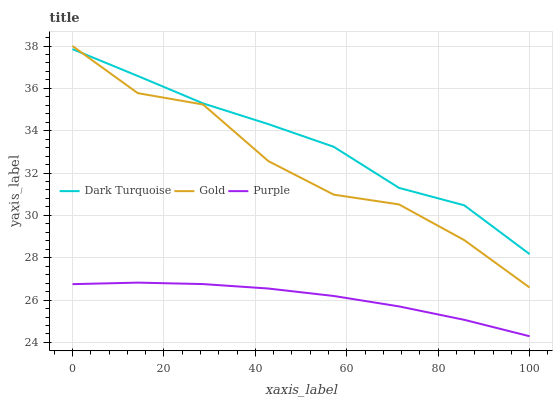Does Purple have the minimum area under the curve?
Answer yes or no. Yes. Does Dark Turquoise have the maximum area under the curve?
Answer yes or no. Yes. Does Gold have the minimum area under the curve?
Answer yes or no. No. Does Gold have the maximum area under the curve?
Answer yes or no. No. Is Purple the smoothest?
Answer yes or no. Yes. Is Gold the roughest?
Answer yes or no. Yes. Is Dark Turquoise the smoothest?
Answer yes or no. No. Is Dark Turquoise the roughest?
Answer yes or no. No. Does Purple have the lowest value?
Answer yes or no. Yes. Does Gold have the lowest value?
Answer yes or no. No. Does Gold have the highest value?
Answer yes or no. Yes. Does Dark Turquoise have the highest value?
Answer yes or no. No. Is Purple less than Dark Turquoise?
Answer yes or no. Yes. Is Dark Turquoise greater than Purple?
Answer yes or no. Yes. Does Gold intersect Dark Turquoise?
Answer yes or no. Yes. Is Gold less than Dark Turquoise?
Answer yes or no. No. Is Gold greater than Dark Turquoise?
Answer yes or no. No. Does Purple intersect Dark Turquoise?
Answer yes or no. No. 